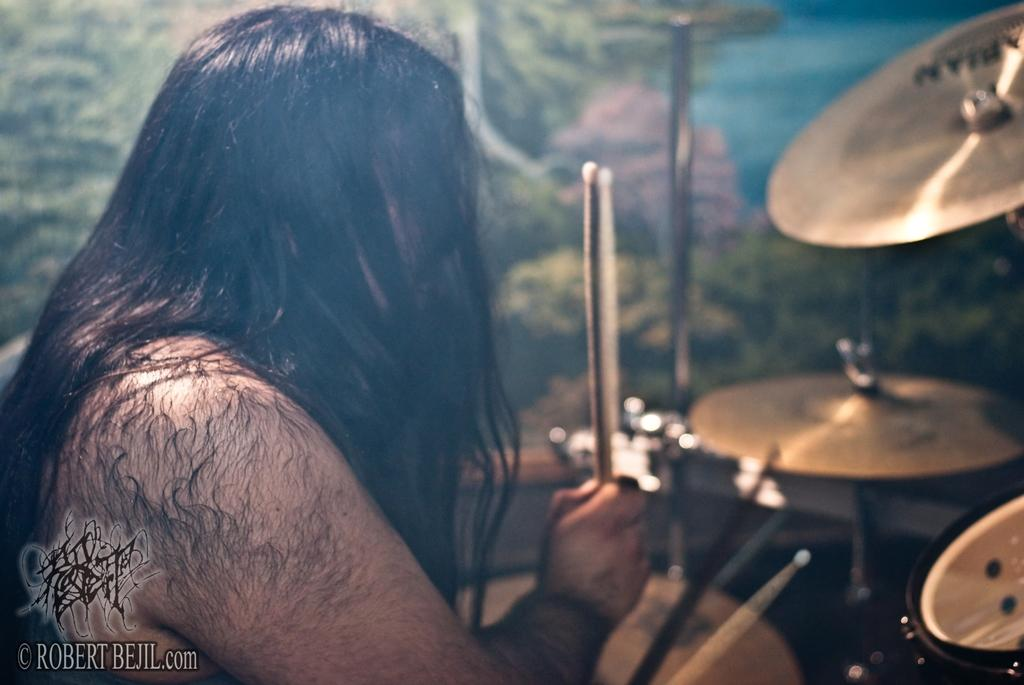What is the man in the image doing? The man is playing drums in the image. What is the man using to play the drums? The man is using sticks in his hands to play the drums. Can you describe any other objects or features in the image? There is a watermark at the bottom left corner of the image and a frame on the wall. What type of jeans is the horse wearing in the image? There is no horse or jeans present in the image. What is the man learning to play in the image? The image does not show the man learning to play anything; he is already appears to be playing the drums. 